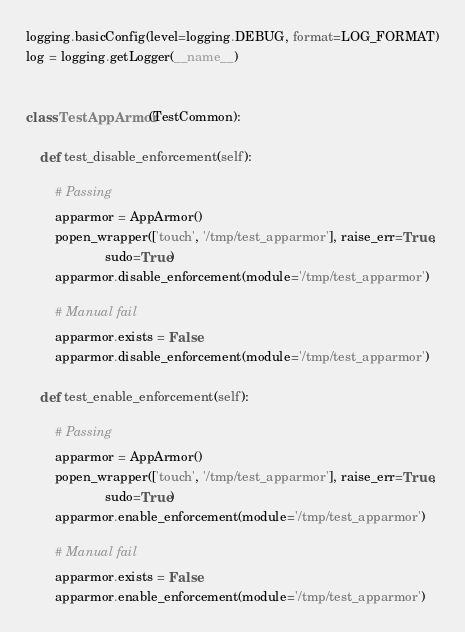Convert code to text. <code><loc_0><loc_0><loc_500><loc_500><_Python_>logging.basicConfig(level=logging.DEBUG, format=LOG_FORMAT)
log = logging.getLogger(__name__)


class TestAppArmor(TestCommon):

    def test_disable_enforcement(self):

        # Passing
        apparmor = AppArmor()
        popen_wrapper(['touch', '/tmp/test_apparmor'], raise_err=True,
                      sudo=True)
        apparmor.disable_enforcement(module='/tmp/test_apparmor')

        # Manual fail
        apparmor.exists = False
        apparmor.disable_enforcement(module='/tmp/test_apparmor')

    def test_enable_enforcement(self):

        # Passing
        apparmor = AppArmor()
        popen_wrapper(['touch', '/tmp/test_apparmor'], raise_err=True,
                      sudo=True)
        apparmor.enable_enforcement(module='/tmp/test_apparmor')

        # Manual fail
        apparmor.exists = False
        apparmor.enable_enforcement(module='/tmp/test_apparmor')
</code> 